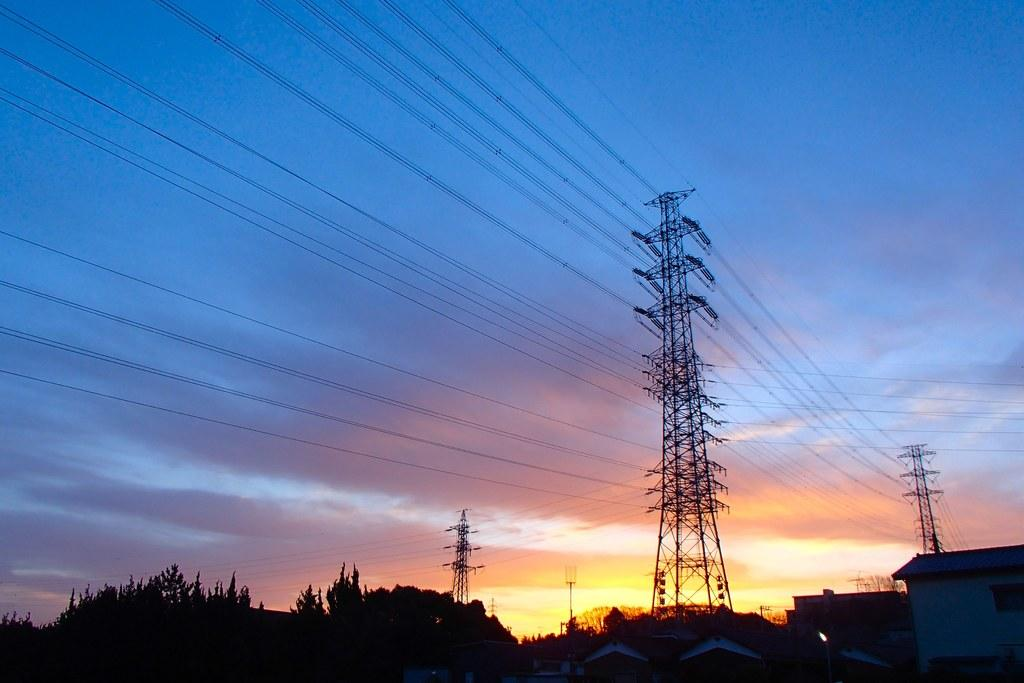What is the color of the sky in the image? The sky is blue in color. Are there any weather elements visible in the image? Yes, there are clouds visible in the image. What type of structures can be seen in the image? There are buildings in the image. What other natural elements are present in the image? There are trees in the image. What type of stick can be seen bursting through the clouds in the image? There is no stick or any object bursting through the clouds in the image. 